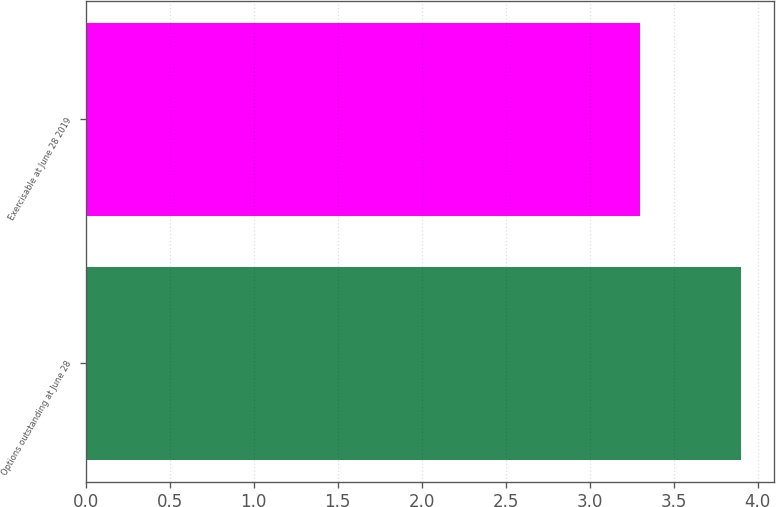<chart> <loc_0><loc_0><loc_500><loc_500><bar_chart><fcel>Options outstanding at June 28<fcel>Exercisable at June 28 2019<nl><fcel>3.9<fcel>3.3<nl></chart> 